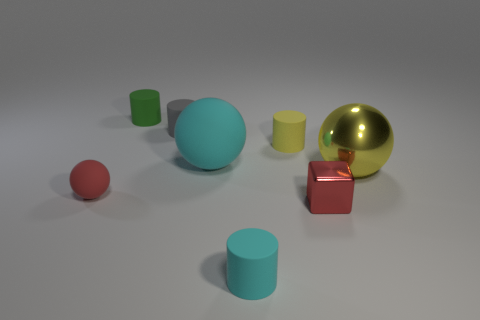There is another tiny thing that is the same color as the tiny metal object; what is its shape?
Provide a succinct answer. Sphere. What is the material of the cylinder that is right of the large rubber object and behind the tiny cube?
Make the answer very short. Rubber. How many spheres are red rubber things or cyan objects?
Your response must be concise. 2. There is a small yellow object that is the same shape as the green matte thing; what material is it?
Keep it short and to the point. Rubber. The green thing that is made of the same material as the gray cylinder is what size?
Offer a terse response. Small. Does the small rubber object that is on the left side of the green rubber thing have the same shape as the large object that is in front of the large cyan sphere?
Keep it short and to the point. Yes. There is a large ball that is the same material as the small green thing; what is its color?
Make the answer very short. Cyan. There is a cyan rubber cylinder that is on the right side of the gray cylinder; is it the same size as the cyan thing behind the big yellow ball?
Make the answer very short. No. What shape is the small thing that is to the left of the red metallic block and in front of the tiny red matte sphere?
Keep it short and to the point. Cylinder. Are there any small green things that have the same material as the small yellow thing?
Provide a short and direct response. Yes. 